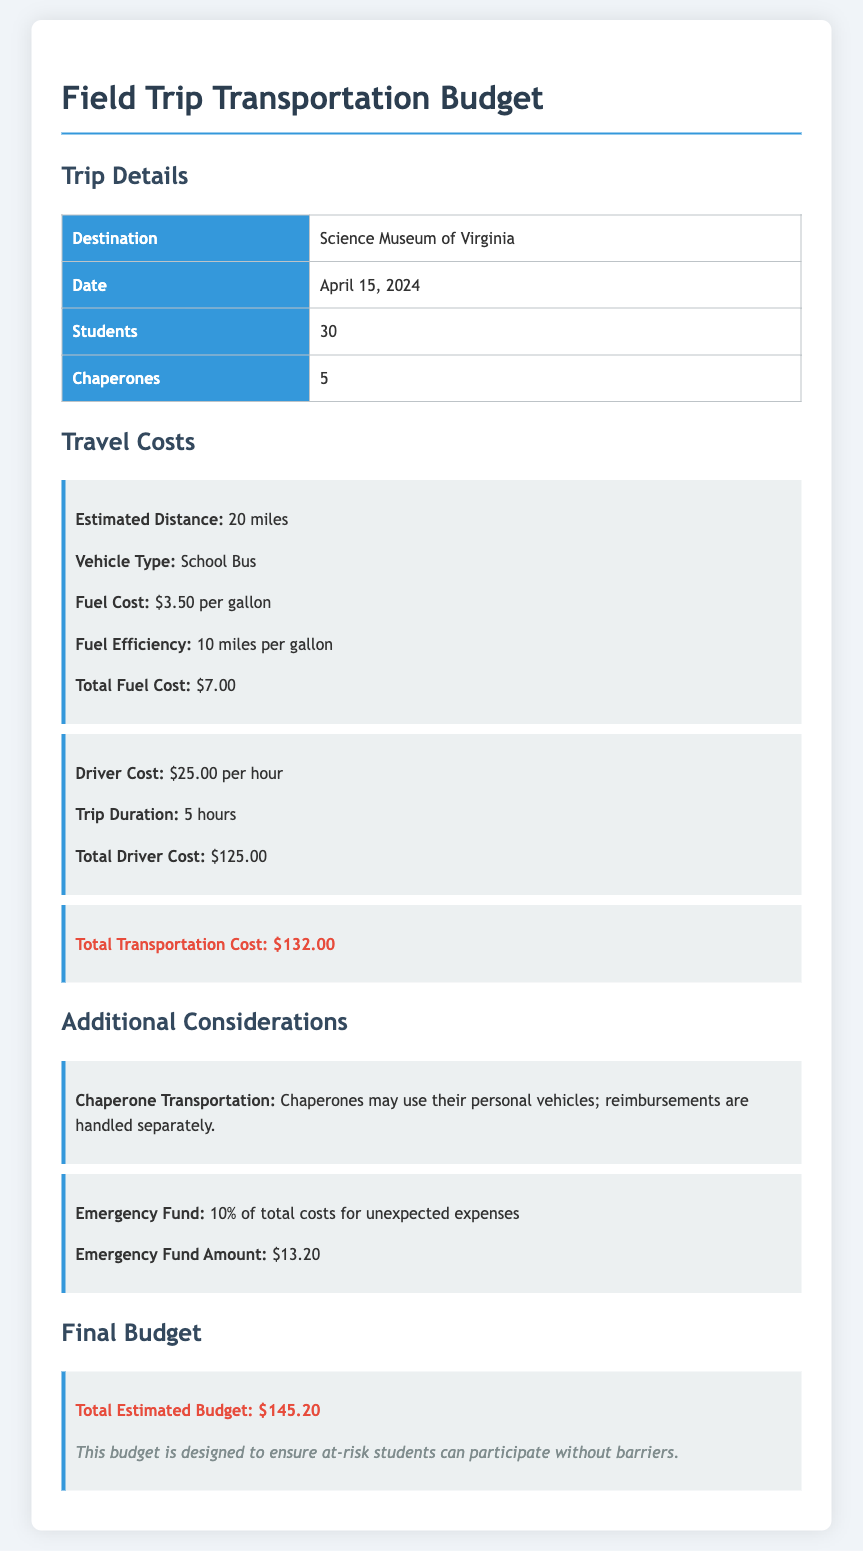What is the destination of the trip? The document states that the destination of the trip is the Science Museum of Virginia.
Answer: Science Museum of Virginia What is the date of the field trip? The field trip is scheduled for April 15, 2024, as mentioned in the document.
Answer: April 15, 2024 How many students are attending the trip? The document indicates that 30 students will be participating in the field trip.
Answer: 30 What is the total fuel cost? The total fuel cost is provided in the document as $7.00 based on the estimated distance and fuel efficiency.
Answer: $7.00 How long is the trip duration? The trip duration is stated in the document to be 5 hours.
Answer: 5 hours What is the cost per hour for the driver? The document specifies that the driver cost is $25.00 per hour.
Answer: $25.00 What percentage of the total costs is allocated for the emergency fund? The document states that 10% of total costs are allocated for the emergency fund.
Answer: 10% What is the total transportation cost? The total transportation cost is detailed in the document as $132.00.
Answer: $132.00 What is the total estimated budget for the trip? The document concludes with a final estimated budget of $145.20 for the trip.
Answer: $145.20 